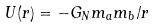<formula> <loc_0><loc_0><loc_500><loc_500>U ( r ) = - G _ { N } m _ { a } m _ { b } / r</formula> 